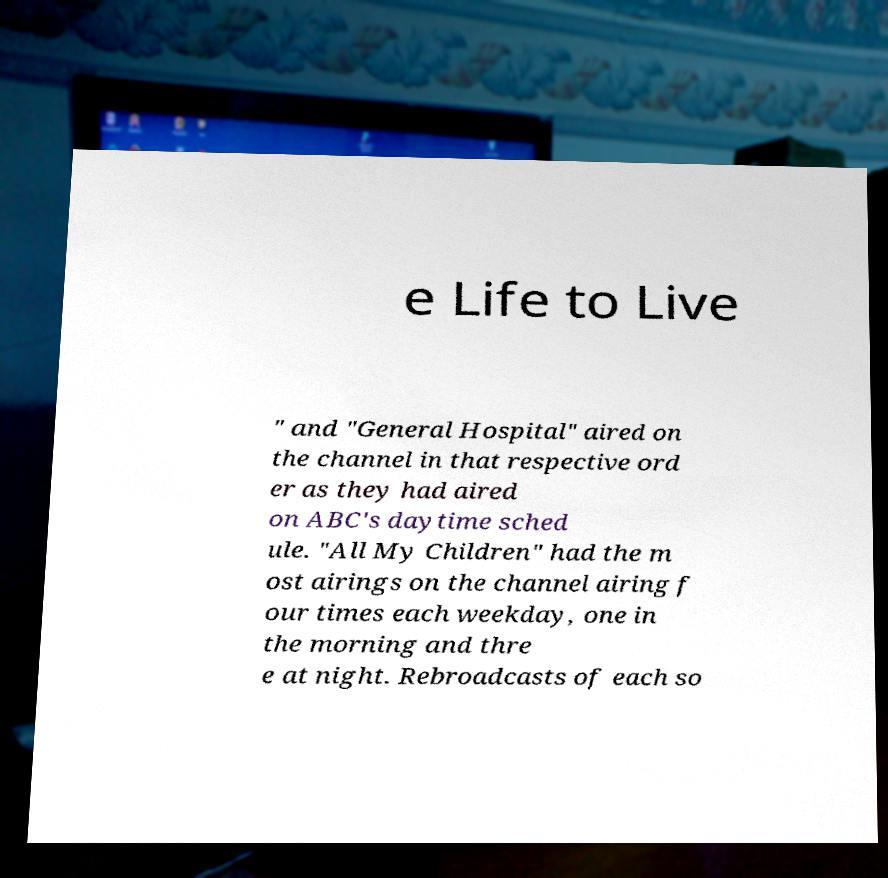Could you extract and type out the text from this image? e Life to Live " and "General Hospital" aired on the channel in that respective ord er as they had aired on ABC's daytime sched ule. "All My Children" had the m ost airings on the channel airing f our times each weekday, one in the morning and thre e at night. Rebroadcasts of each so 